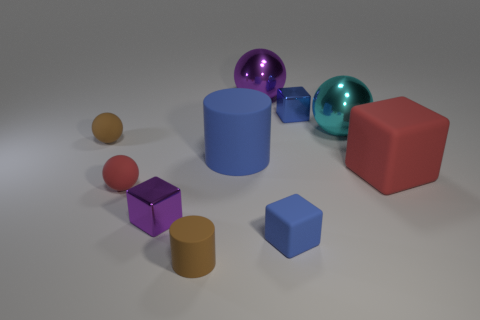Subtract all brown balls. How many balls are left? 3 Subtract all big purple spheres. How many spheres are left? 3 Subtract all yellow blocks. Subtract all yellow balls. How many blocks are left? 4 Subtract all cubes. How many objects are left? 6 Subtract all purple things. Subtract all small metal objects. How many objects are left? 6 Add 5 big cylinders. How many big cylinders are left? 6 Add 9 tiny green rubber cubes. How many tiny green rubber cubes exist? 9 Subtract 0 green cubes. How many objects are left? 10 